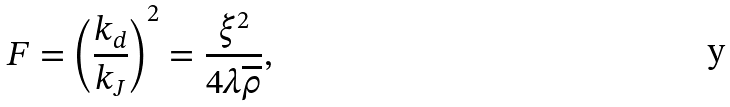<formula> <loc_0><loc_0><loc_500><loc_500>F = \left ( \frac { k _ { d } } { k _ { J } } \right ) ^ { 2 } = \frac { \xi ^ { 2 } } { 4 \lambda \overline { \rho } } ,</formula> 